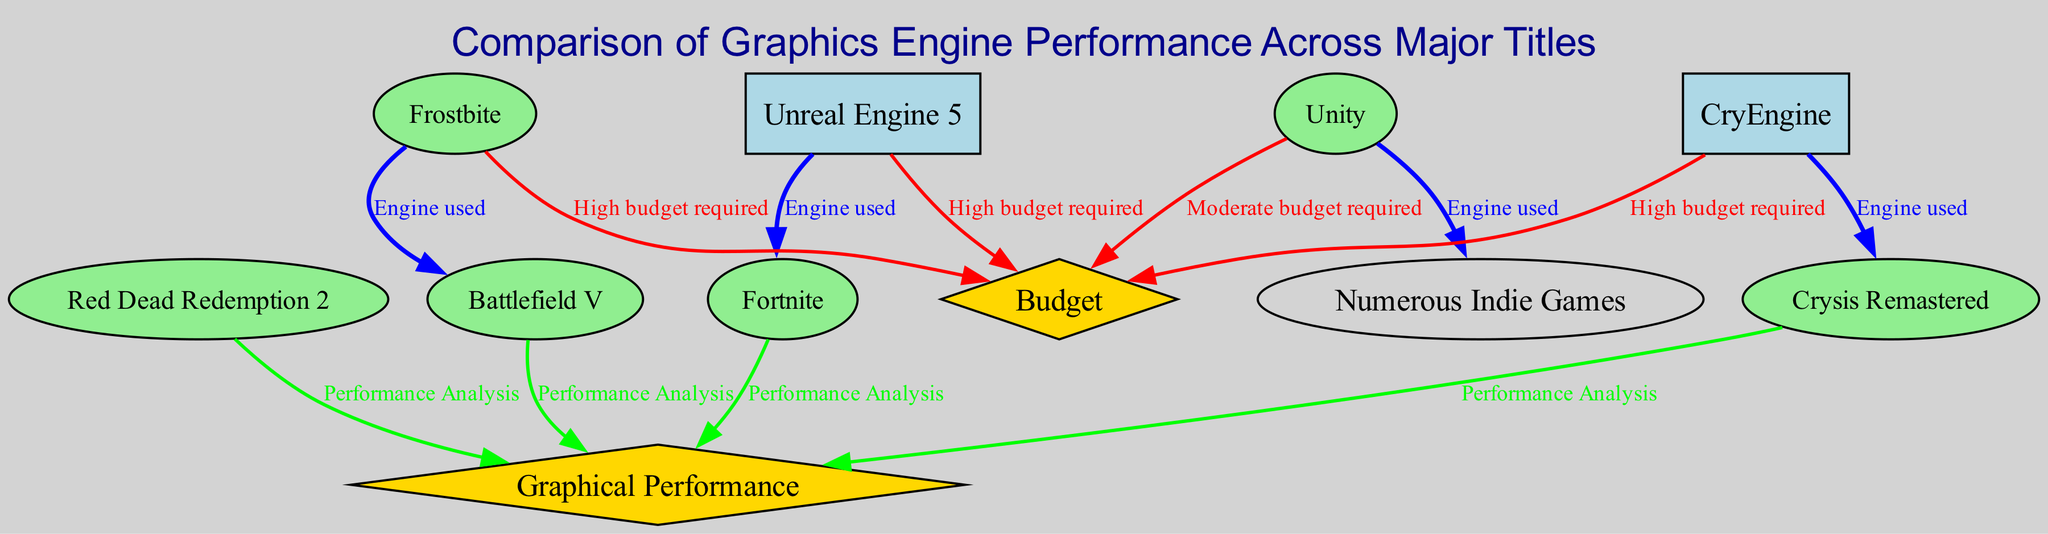What game is powered by Unreal Engine 5? By tracing the edge labeled "Engine used" from the node "Unreal Engine 5," we connect it to the node "Fortnite." This direct connection indicates that Fortnite is a game that uses Unreal Engine 5.
Answer: Fortnite Which graphical engine is used in Battlefield V? The edge going from "Frostbite" to "Battlefield V" is labeled "Engine used," showing that Battlefield V utilizes the Frostbite engine for its graphics.
Answer: Frostbite How many games are analyzed for graphical performance? There are four games connected to the "Graphical Performance" node via edges labeled "Performance Analysis": "Red Dead Redemption 2," "Fortnite," "Battlefield V," and "Crysis Remastered." Counting these connections gives the total.
Answer: Four What does the node labeled "Budget" signify? The node "Budget" is represented in a diamond shape and is described as "Funds allocated for graphics development." Thus, it signifies the financial resources essential for developing graphics in games.
Answer: Funds allocated for graphics development Which engine requires a high budget? The edges from the nodes "Unreal Engine 5," "Frostbite," and "CryEngine" to the node "Budget" indicate that all these engines require a high budget. This can be inferred because they all connect to the same node.
Answer: Unreal Engine 5, Frostbite, CryEngine Which game has award-winning visuals? The node labeled "Red Dead Redemption 2" includes the description "Award-winning visuals," thus directly indicating its recognition for high-quality graphics.
Answer: Red Dead Redemption 2 What type of graphics quality does Unreal Engine 5 provide? The details provided for the node "Unreal Engine 5" state it offers "High fidelity, top-tier photorealistic graphics," which gives a clear description of the graphics quality it supports.
Answer: High fidelity, top-tier photorealistic graphics What is the relationship between CryEngine and Crysis Remastered? The edge between "CryEngine" and "Crysis Remastered" is labeled "Engine used," indicating that Crysis Remastered relies on CryEngine for its graphics development.
Answer: Engine used 